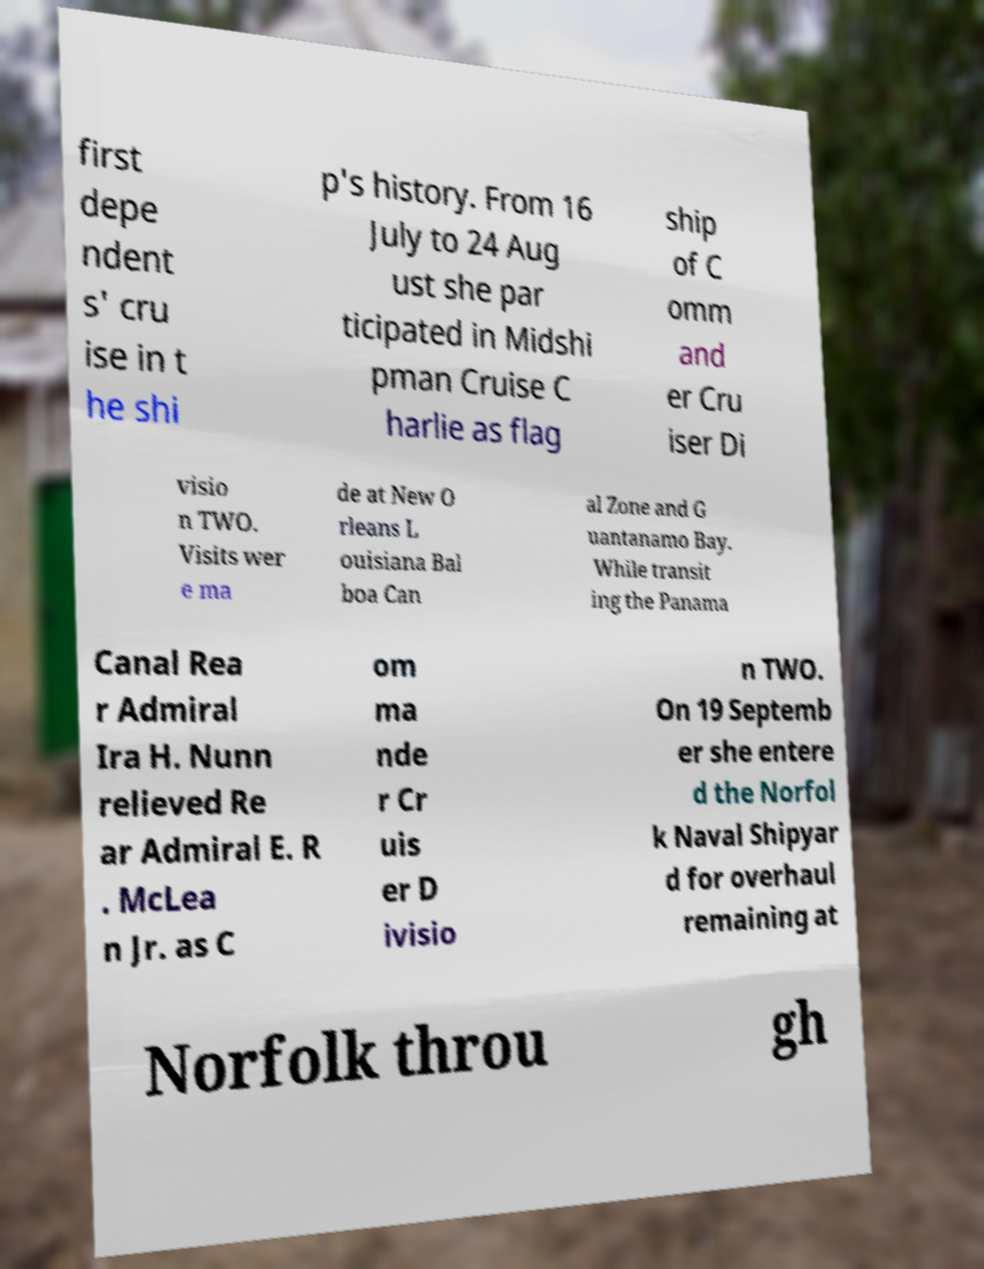What messages or text are displayed in this image? I need them in a readable, typed format. first depe ndent s' cru ise in t he shi p's history. From 16 July to 24 Aug ust she par ticipated in Midshi pman Cruise C harlie as flag ship of C omm and er Cru iser Di visio n TWO. Visits wer e ma de at New O rleans L ouisiana Bal boa Can al Zone and G uantanamo Bay. While transit ing the Panama Canal Rea r Admiral Ira H. Nunn relieved Re ar Admiral E. R . McLea n Jr. as C om ma nde r Cr uis er D ivisio n TWO. On 19 Septemb er she entere d the Norfol k Naval Shipyar d for overhaul remaining at Norfolk throu gh 